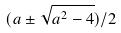<formula> <loc_0><loc_0><loc_500><loc_500>( a \pm \sqrt { a ^ { 2 } - 4 } ) / 2</formula> 